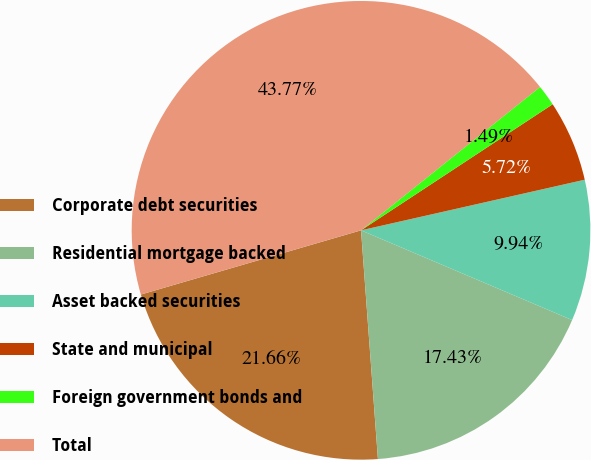Convert chart to OTSL. <chart><loc_0><loc_0><loc_500><loc_500><pie_chart><fcel>Corporate debt securities<fcel>Residential mortgage backed<fcel>Asset backed securities<fcel>State and municipal<fcel>Foreign government bonds and<fcel>Total<nl><fcel>21.66%<fcel>17.43%<fcel>9.94%<fcel>5.72%<fcel>1.49%<fcel>43.77%<nl></chart> 